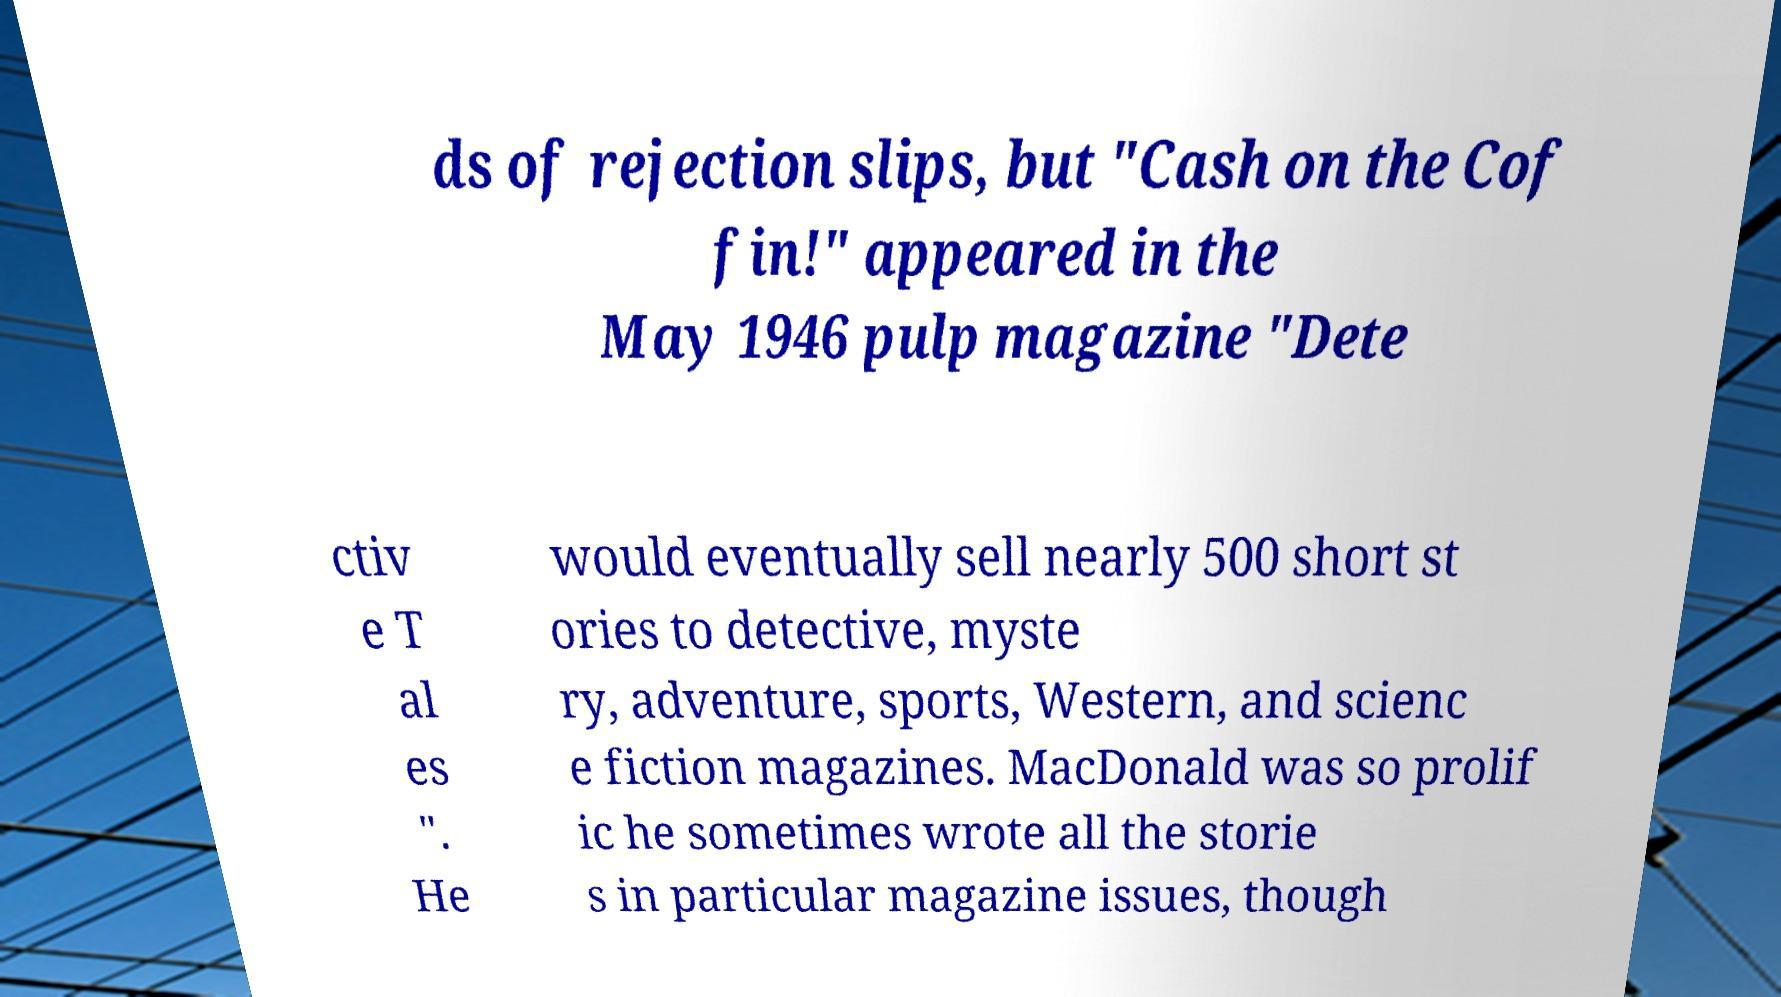Can you read and provide the text displayed in the image?This photo seems to have some interesting text. Can you extract and type it out for me? ds of rejection slips, but "Cash on the Cof fin!" appeared in the May 1946 pulp magazine "Dete ctiv e T al es ". He would eventually sell nearly 500 short st ories to detective, myste ry, adventure, sports, Western, and scienc e fiction magazines. MacDonald was so prolif ic he sometimes wrote all the storie s in particular magazine issues, though 